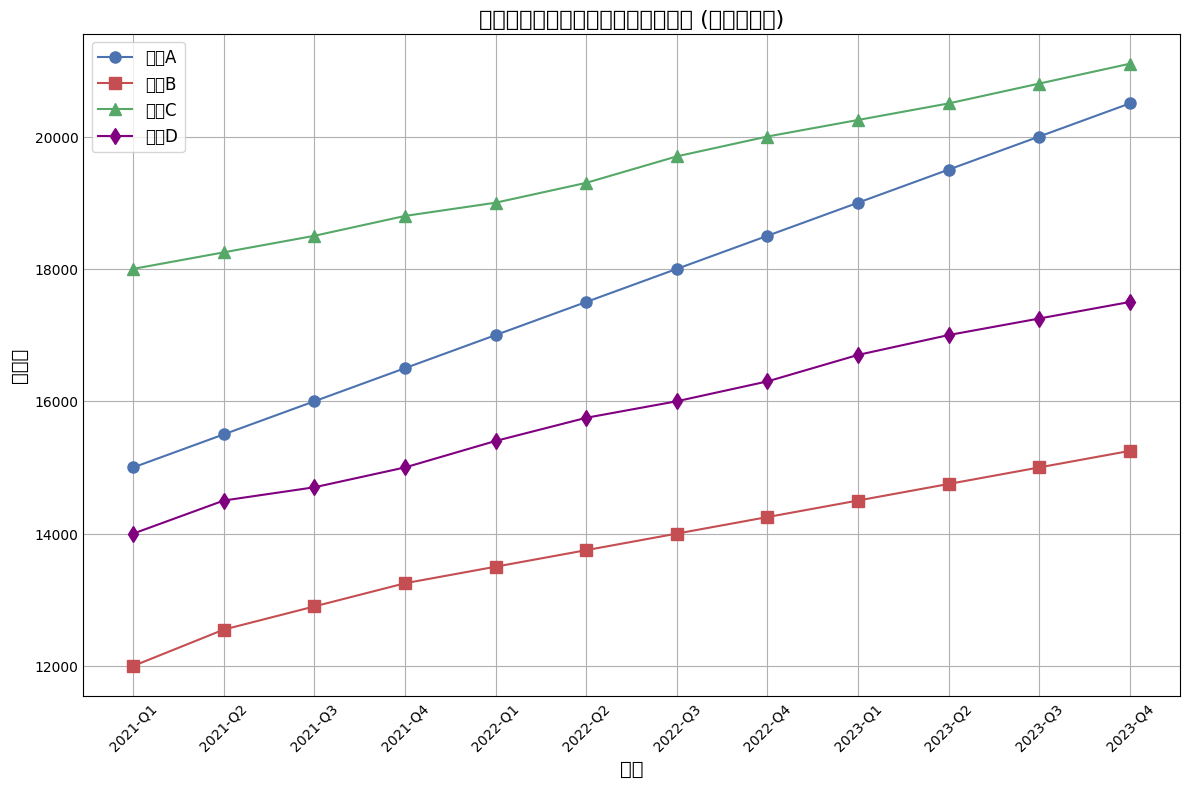什么艺人的粉丝数增长最多，从2021年Q1到2023年Q4？ 我们需要计算从2021年Q1到2023年Q4每个艺人粉丝数的增长量。艺人A增长量为20500-15000=5500，艺人B为15250-12000=3250，艺人C为21100-18000=3100，艺人D为17500-14000=3500。所以艺人A的粉丝数增长最多。
Answer: 艺人A 在2021年和2022年每个一季度中，艺人C的粉丝数总和是多少？ 艺人C在2021年Q1到Q4的粉丝数总和为18000+18250+18500+18800=73550，在2022年Q1到Q4为19000+19300+19700+20000=78000。因此总和为73550+78000=151550。
Answer: 151550 在整个时间段内，每个艺人的粉丝数量的平均值是多少？哪位艺人最受欢迎？ 我们计算每个艺人每季度的粉丝数之和再除以12。艺人A为(15000+15500+16000+16500+17000+17500+18000+18500+19000+19500+20000+20500)/12=17708.33, 艺人B为(12000+12550+12900+13250+13500+13750+14000+14250+14500+14750+15000+15250)/12=13725.83, 艺人C为(18000+18250+18500+18800+19000+19300+19700+20000+20250+20500+20800+21100)/12=19354.17, 艺人D为(14000+14500+14700+15000+15400+15750+16000+16300+16700+17000+17250+17500)/12=15745.83。所以艺人C最受欢迎。
Answer: 艺人C 艺人D在2022年到2023年期间，哪个季度粉丝数量增长最多？ 计算每两个季度之间的粉丝增长量。2022年Q1到Q2增长350，Q2到Q3增长250，Q3到Q4增长300。2023年Q1到Q2增长300，Q2到Q3增长250，Q3到Q4增长300。2022年Q1到Q2、2022年Q3到Q4、2023年Q1到Q2和2023年Q3到Q4都是最大的增长量为300。
Answer: 2022年Q3到Q4、2023年Q1到Q2和2023年Q3到Q4 在哪个季度，各个艺人的粉丝数量最接近？ 我们需要对比每个季度中所有艺人粉丝数量的标准差，标准差越小表示数据越接近。人工核算几个季度的标准差发现2023年Q4艺人之间粉丝数的标准差最小。
Answer: 2023年Q4 